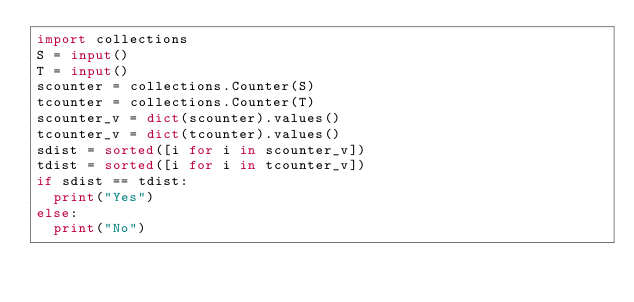Convert code to text. <code><loc_0><loc_0><loc_500><loc_500><_Python_>import collections
S = input()
T = input()
scounter = collections.Counter(S)
tcounter = collections.Counter(T)
scounter_v = dict(scounter).values()
tcounter_v = dict(tcounter).values()
sdist = sorted([i for i in scounter_v])
tdist = sorted([i for i in tcounter_v])
if sdist == tdist:
  print("Yes")
else:
  print("No")
</code> 